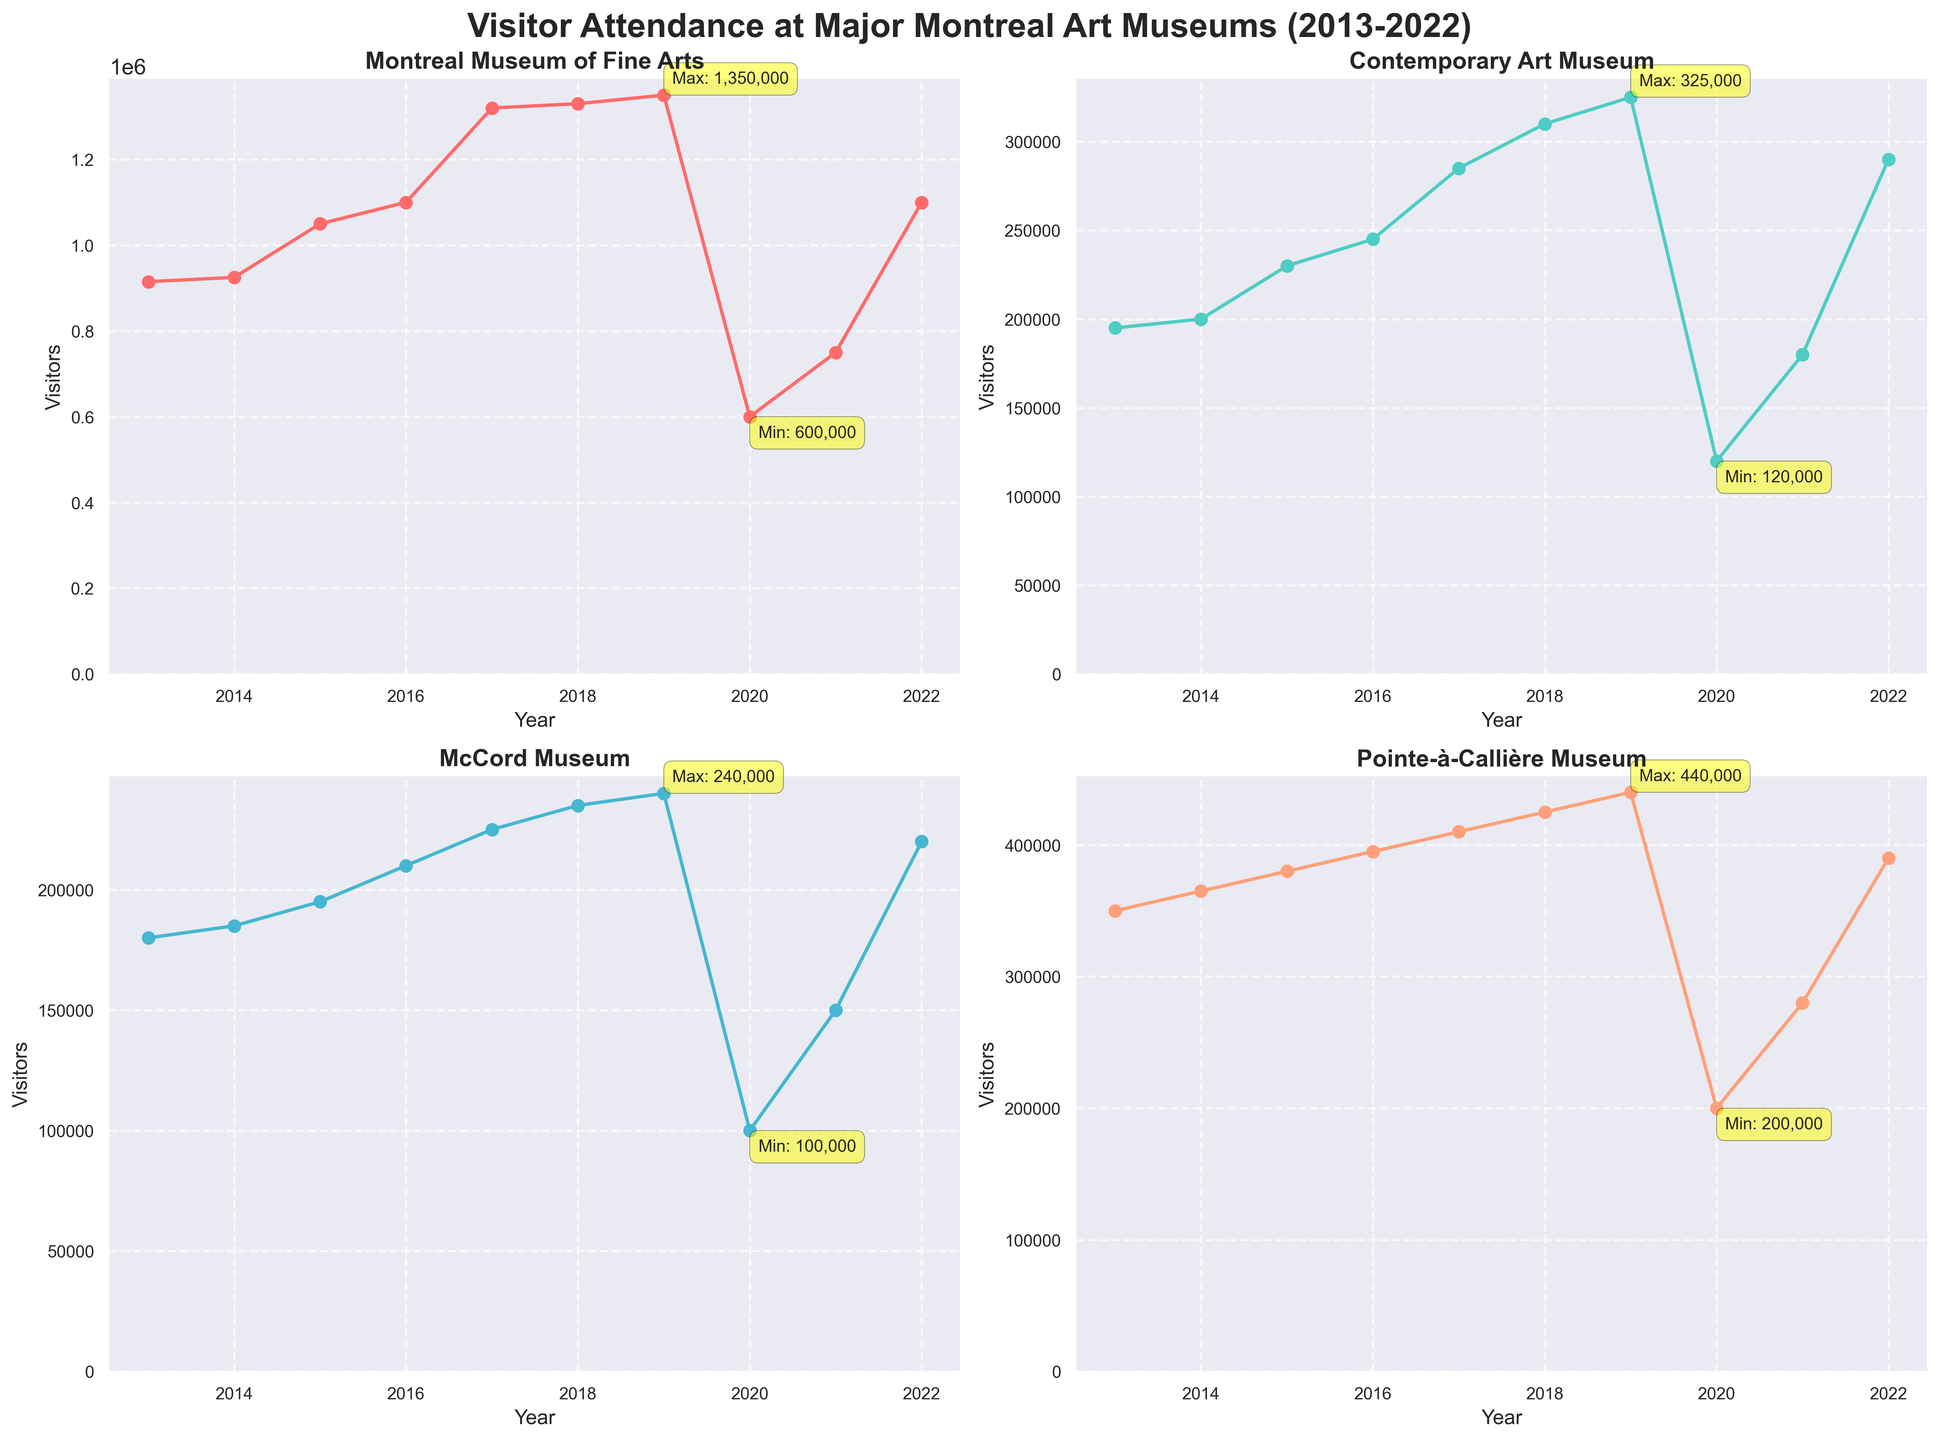What's the highest visitor attendance for the Montreal Museum of Fine Arts? The subplot for the Montreal Museum of Fine Arts shows a peak in visitor attendance in 2019 with an annotated value.
Answer: 1,350,000 What year had the lowest visitor attendance for the Contemporary Art Museum? By looking at the subplot for the Contemporary Art Museum, the annotated minimum is in 2020.
Answer: 2020 Which museum had the sharpest decline in visitor attendance between 2019 and 2020? By comparing the subplots, the Montreal Museum of Fine Arts shows the largest drop between these years, from 1,350,000 to 600,000.
Answer: Montreal Museum of Fine Arts How did the visitor attendance for McCord Museum change between 2017 and 2020? Viewing the McCord Museum subplot, the attendance drops from 225,000 in 2017 to 100,000 in 2020.
Answer: Decreased by 125,000 What was the visitor attendance for Pointe-à-Callière Museum in 2020? The subplot for the Pointe-à-Callière Museum shows an attendance of 200,000 in 2020, annotated as the minimum.
Answer: 200,000 Between which years did the Contemporary Art Museum show the highest increase in visitor attendance? By examining the subplot, the largest increase occurs between 2018 and 2019, where attendance rose from 310,000 to 325,000.
Answer: 2018-2019 What is the trend of visitor attendance for the Montreal Museum of Fine Arts from 2013 to 2019? Observing the subplot, it shows a steady increase from 915,000 in 2013 to 1,350,000 in 2019.
Answer: Increasing trend Which museum had the most stable visitor attendance over the decade? Comparing the subplots, Pointe-à-Callière Museum shows the least fluctuation in attendance, generally increasing each year without major dips.
Answer: Pointe-à-Callière Museum What is the average visitor attendance for the McCord Museum over the past decade? Total visitor attendance from 2013-2022 for the McCord Museum is 2,040,000. Dividing by 10 gives an average.
Answer: 204,000 Did visitor attendance generally recover to pre-pandemic levels by 2022? Comparing 2022 to 2019 levels in each subplot shows that only the Montreal Museum of Fine Arts and McCord Museum reached similar or higher levels.
Answer: Partially 